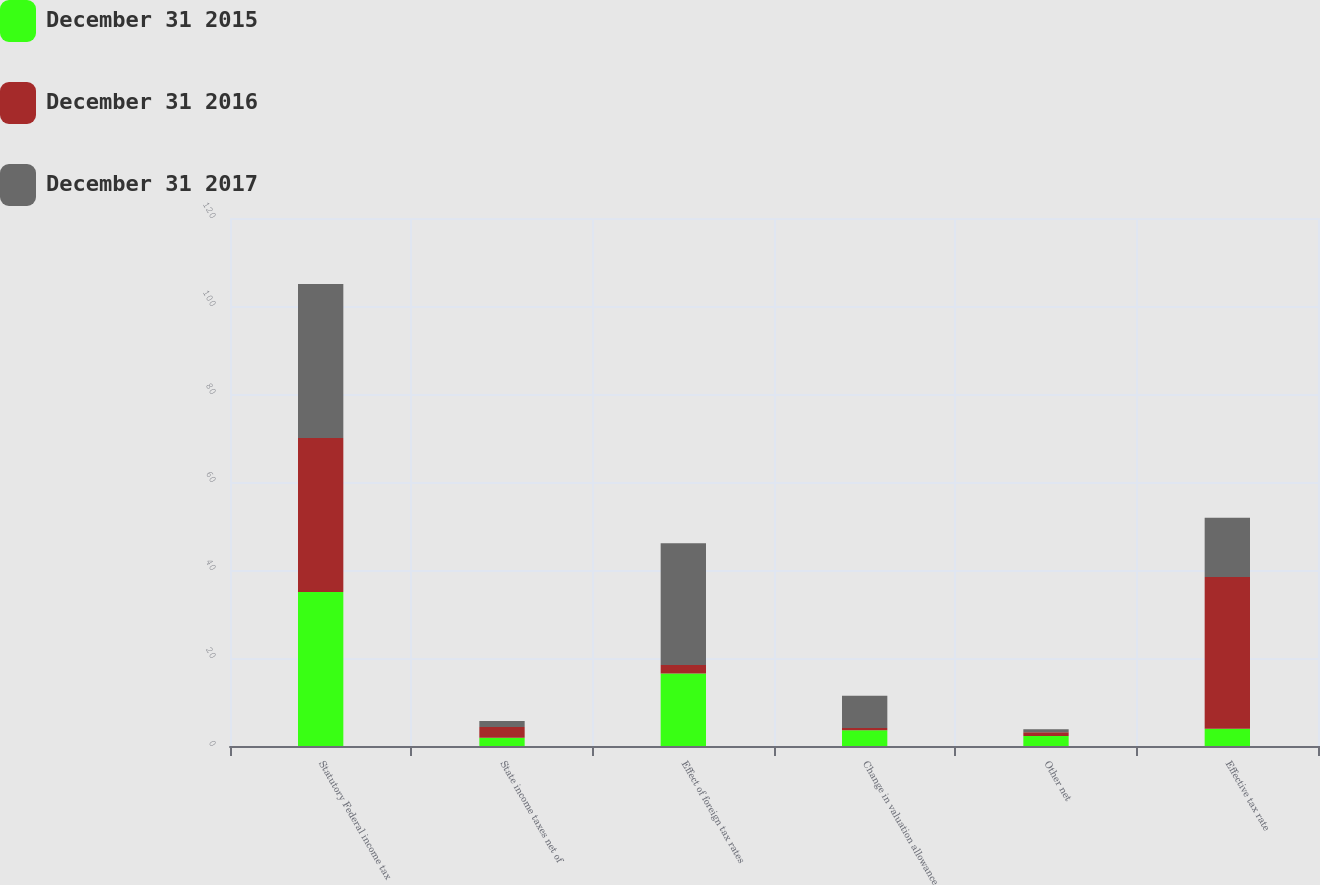Convert chart to OTSL. <chart><loc_0><loc_0><loc_500><loc_500><stacked_bar_chart><ecel><fcel>Statutory Federal income tax<fcel>State income taxes net of<fcel>Effect of foreign tax rates<fcel>Change in valuation allowance<fcel>Other net<fcel>Effective tax rate<nl><fcel>December 31 2015<fcel>35<fcel>1.9<fcel>16.5<fcel>3.6<fcel>2.3<fcel>3.9<nl><fcel>December 31 2016<fcel>35<fcel>2.4<fcel>1.9<fcel>0.5<fcel>0.8<fcel>34.5<nl><fcel>December 31 2017<fcel>35<fcel>1.4<fcel>27.7<fcel>7.3<fcel>0.7<fcel>13.5<nl></chart> 